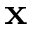<formula> <loc_0><loc_0><loc_500><loc_500>x</formula> 